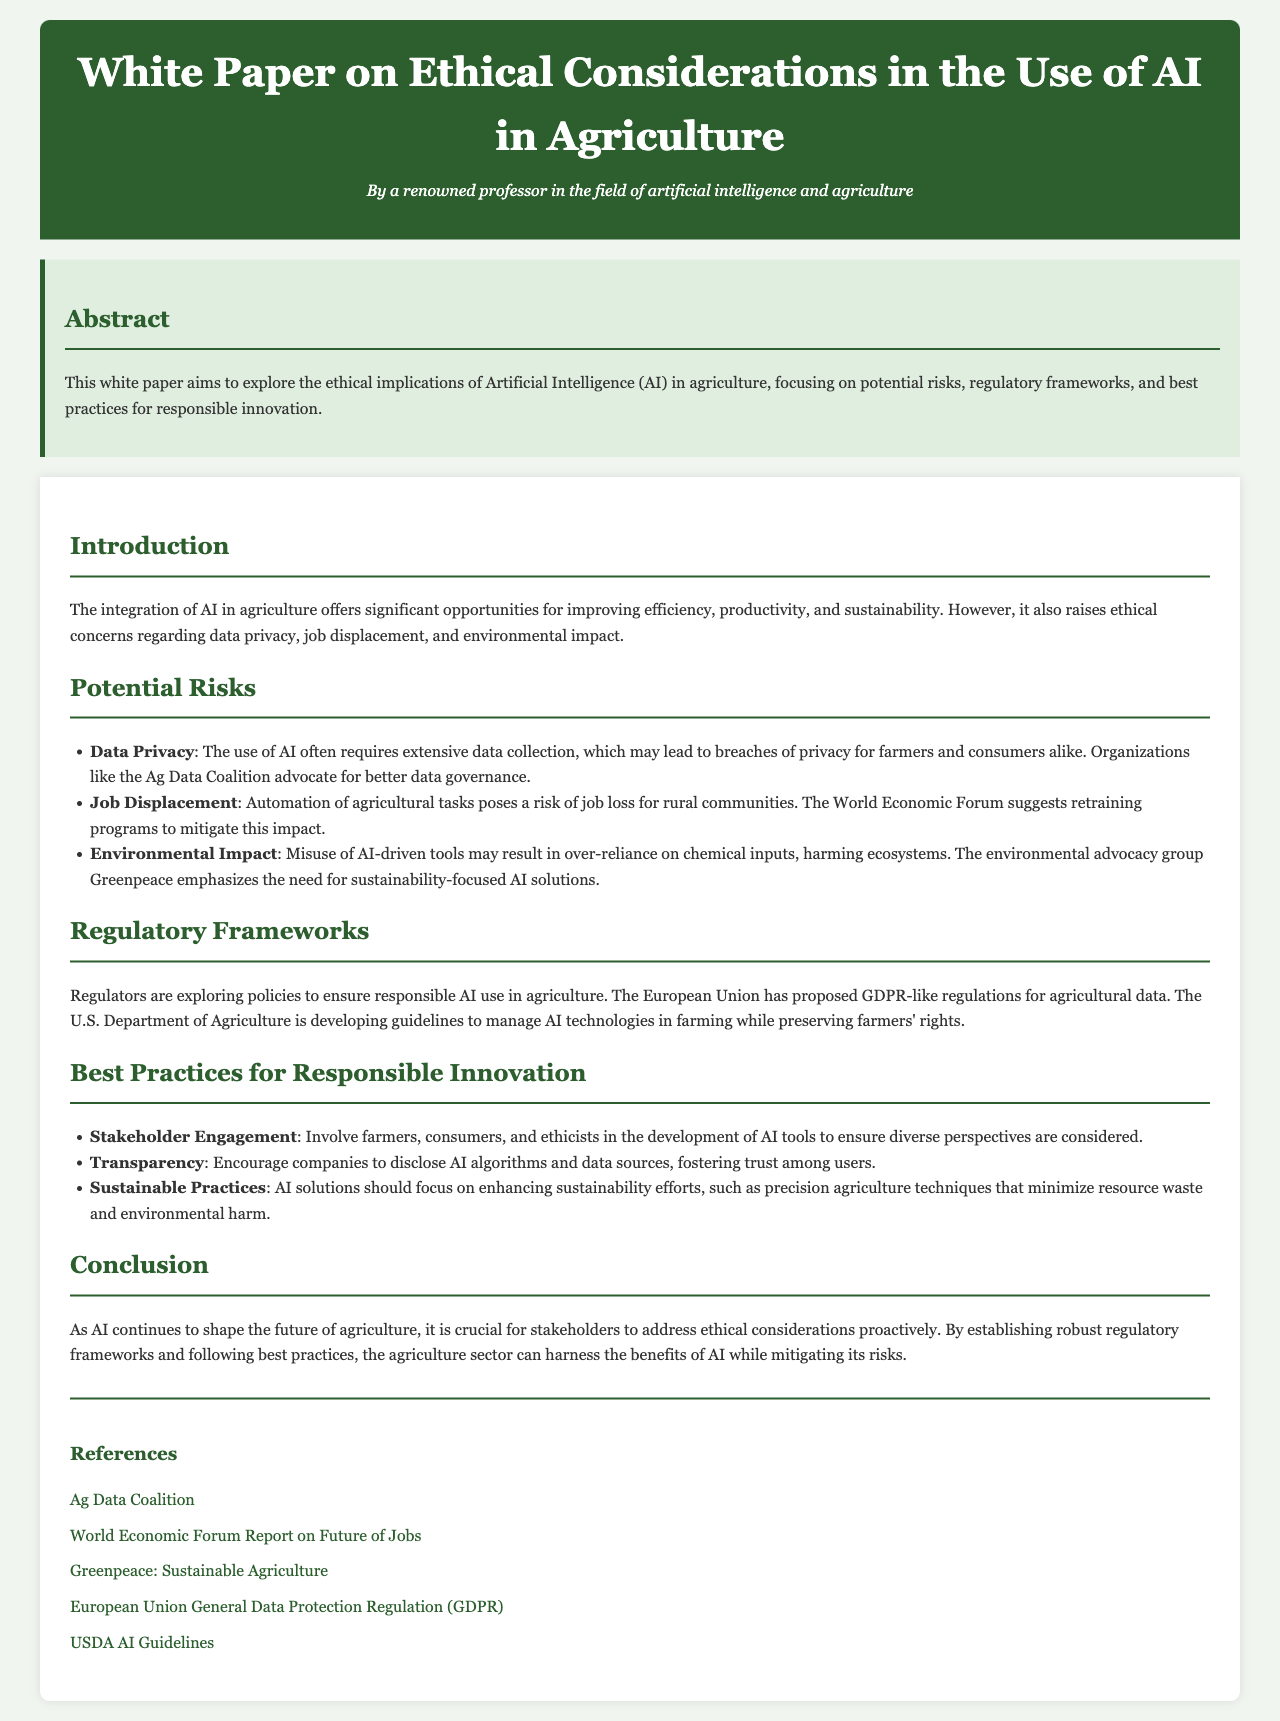What is the title of the document? The title of the document is specified in the header section, which describes the main focus of the paper.
Answer: White Paper on Ethical Considerations in the Use of AI in Agriculture Who is the author of the document? The author is mentioned in the header, showcasing their credentials and relevance to the topic.
Answer: A renowned professor in the field of artificial intelligence and agriculture What are the three potential risks discussed? The risks are listed under the Potential Risks section of the document, highlighting key ethical concerns.
Answer: Data Privacy, Job Displacement, Environmental Impact Which organization advocates for better data governance? The organization is specified in the context of data privacy, emphasizing their role in ethical data management.
Answer: Ag Data Coalition What type of engagement is suggested for responsible innovation? This engagement is proposed in the Best Practices for Responsible Innovation section, focusing on inclusion in AI development.
Answer: Stakeholder Engagement What regulatory framework is mentioned for agricultural data? This framework is discussed within the Regulatory Frameworks section, indicating ongoing efforts for responsible AI usage.
Answer: GDPR-like regulations What is emphasized as a best practice for transparency? This emphasizes the importance of openness in AI, mentioned in the Best Practices for Responsible Innovation section.
Answer: Encourage companies to disclose AI algorithms and data sources Why is retraining important for rural communities? The importance is highlighted in the context of job displacement, indicating a proactive measure for those affected.
Answer: To mitigate job loss What sustainable practice is recommended in the document? This practice aims to enhance environmental responsibility, mentioned in the Best Practices for Responsible Innovation section.
Answer: Precision agriculture techniques 